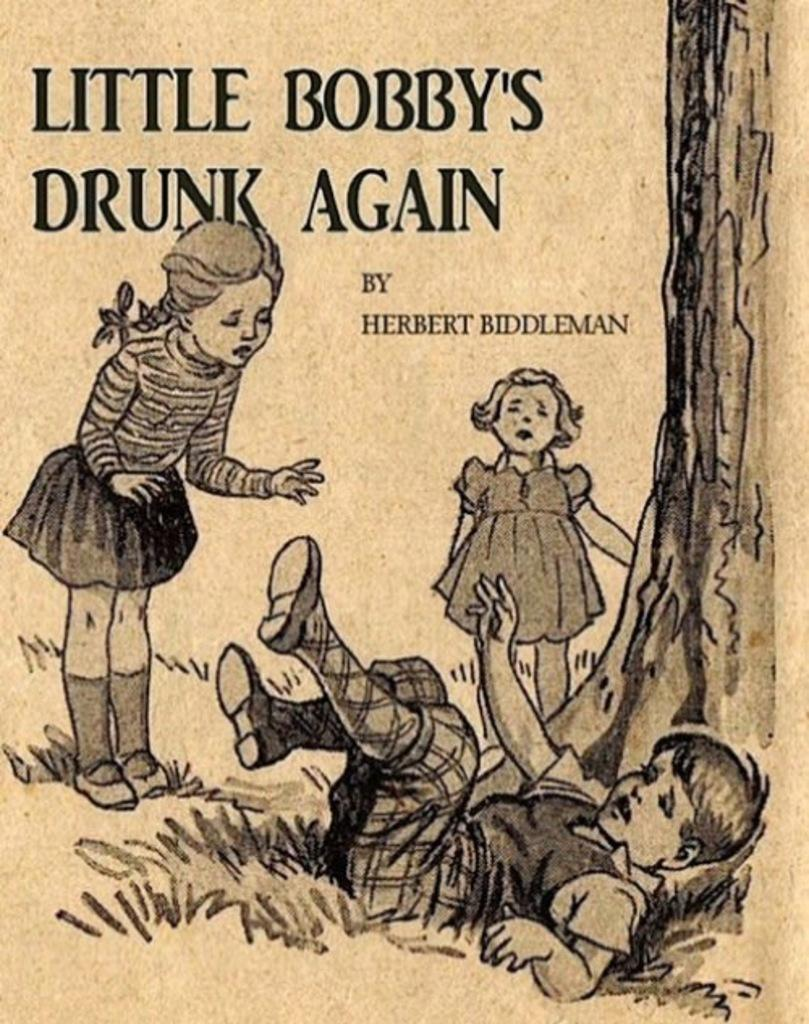How many children are in the image? There are three children in the image. Where are the children located in relation to the image? The children are depicted in front. What type of natural environment is visible in the image? There is grass visible in the image, and there is also a tree. What is written on top of the image? There is text written on top of the image. What type of machine is being used by the children in the image? There is no machine present in the image; the children are simply depicted in front. 